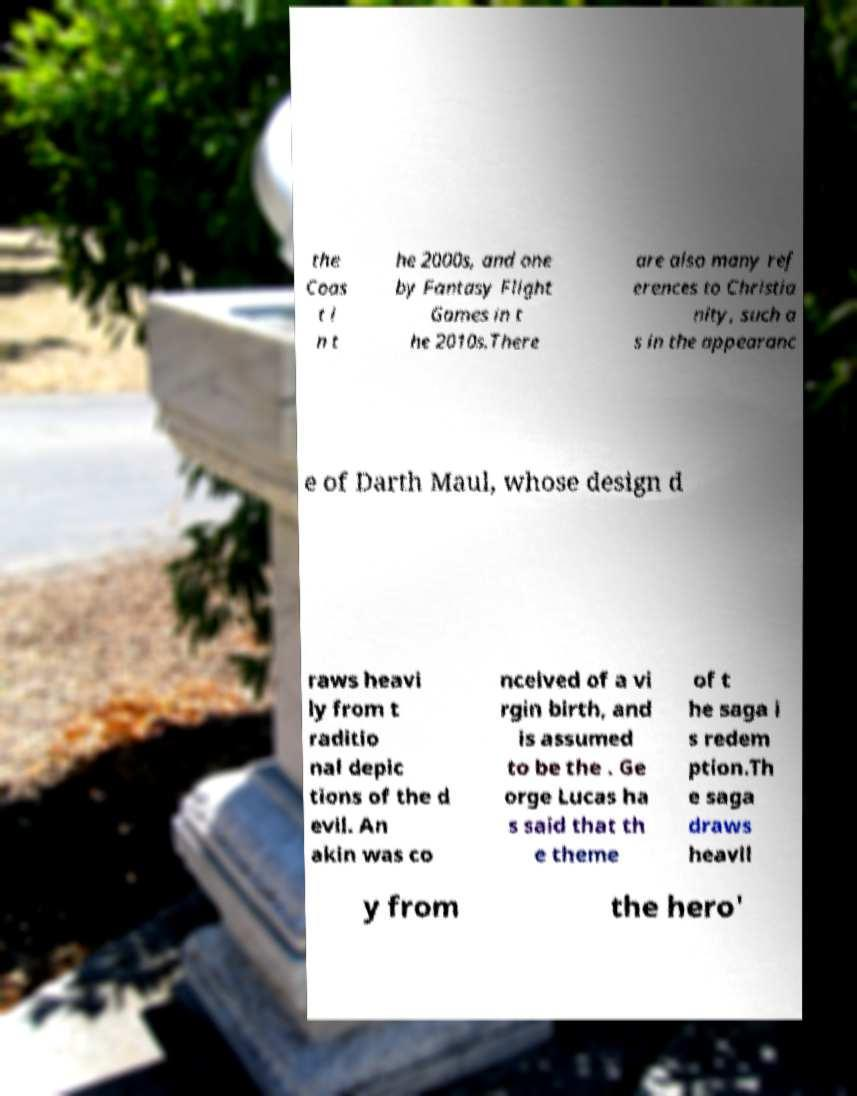What messages or text are displayed in this image? I need them in a readable, typed format. the Coas t i n t he 2000s, and one by Fantasy Flight Games in t he 2010s.There are also many ref erences to Christia nity, such a s in the appearanc e of Darth Maul, whose design d raws heavi ly from t raditio nal depic tions of the d evil. An akin was co nceived of a vi rgin birth, and is assumed to be the . Ge orge Lucas ha s said that th e theme of t he saga i s redem ption.Th e saga draws heavil y from the hero' 